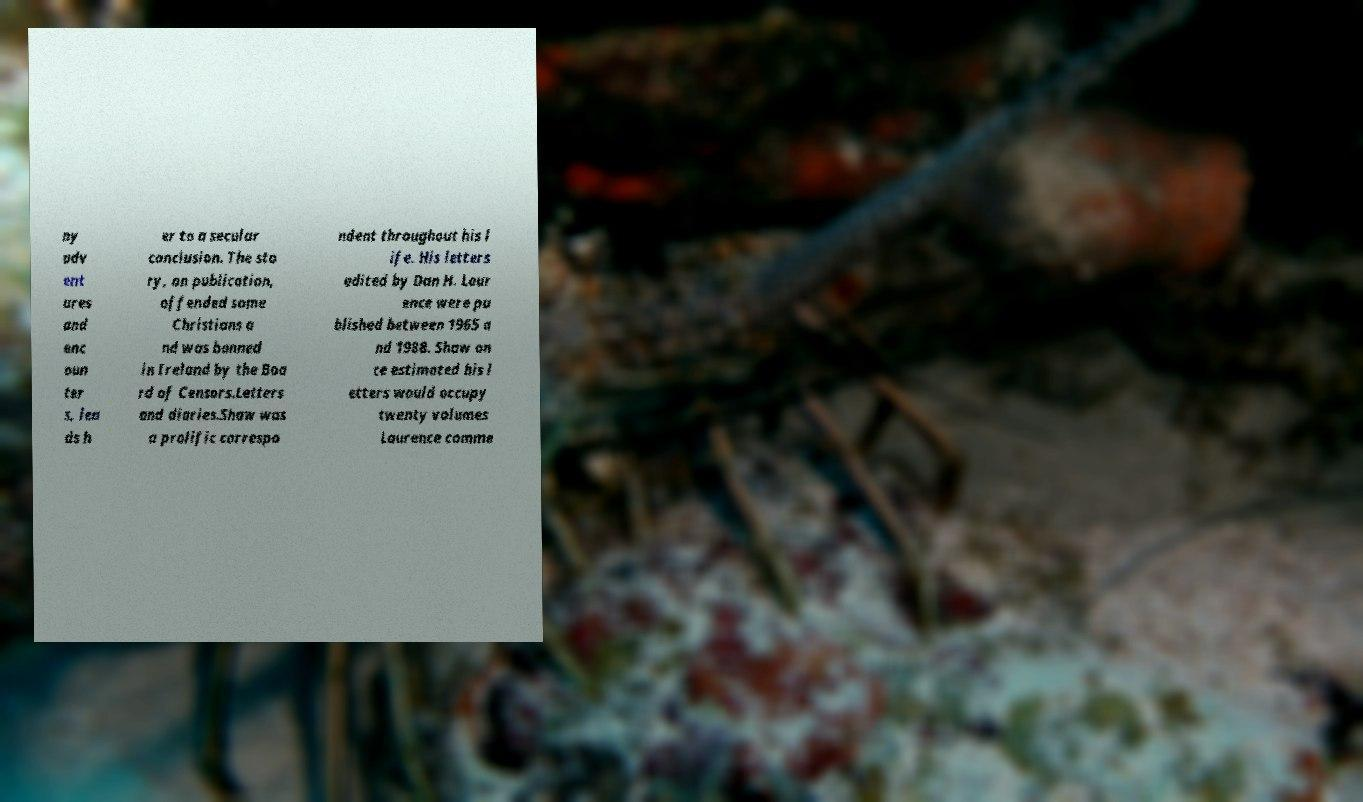There's text embedded in this image that I need extracted. Can you transcribe it verbatim? ny adv ent ures and enc oun ter s, lea ds h er to a secular conclusion. The sto ry, on publication, offended some Christians a nd was banned in Ireland by the Boa rd of Censors.Letters and diaries.Shaw was a prolific correspo ndent throughout his l ife. His letters edited by Dan H. Laur ence were pu blished between 1965 a nd 1988. Shaw on ce estimated his l etters would occupy twenty volumes Laurence comme 